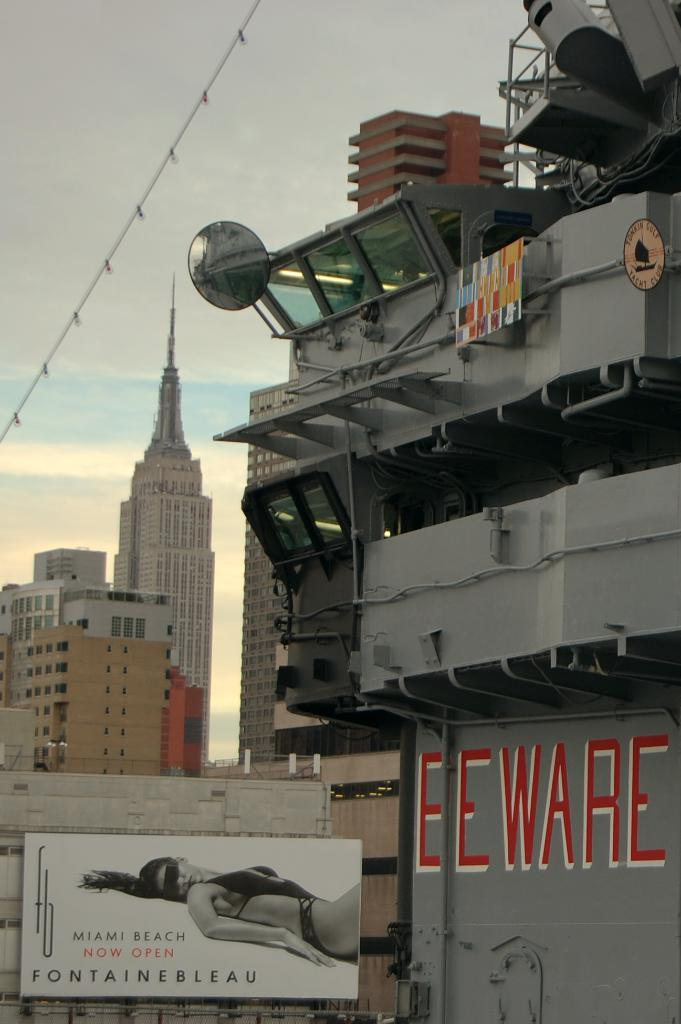What type of structures can be seen in the image? There are many buildings in the image. What material is present in the image? Glass is present in the image. What type of structural elements can be seen in the image? Rods and pipes are visible in the image. What type of signage is present in the image? There is a hoarding in the image. What other objects can be seen in the image? There are other objects in the image. What can be seen in the background of the image? The sky is visible in the background of the image. What type of chess piece is visible on the hoarding in the image? There is no chess piece visible on the hoarding in the image. What type of apparel is being worn by the buildings in the image? Buildings do not wear apparel; they are inanimate structures. 